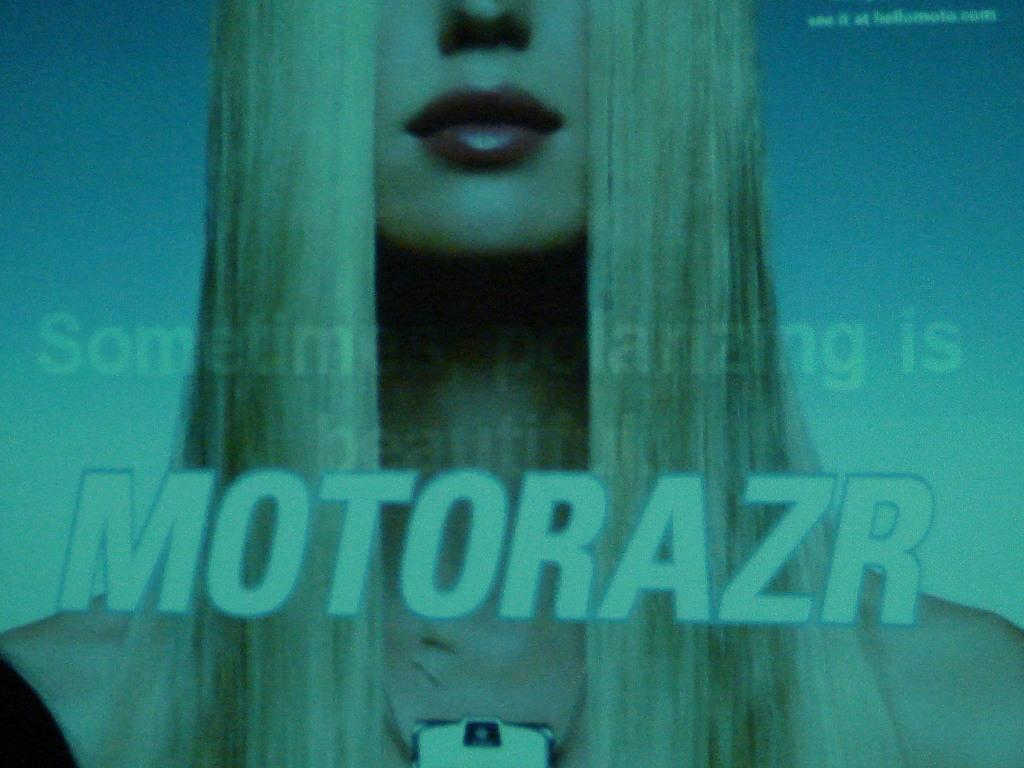Who is present in the image? There is a woman in the image. What else can be seen in the image besides the woman? There is text in the middle of the image. What type of cushion is the kitten sitting on in the image? There is no cushion or kitten present in the image. What is the weather like in the image? The provided facts do not mention any information about the weather, so it cannot be determined from the image. 